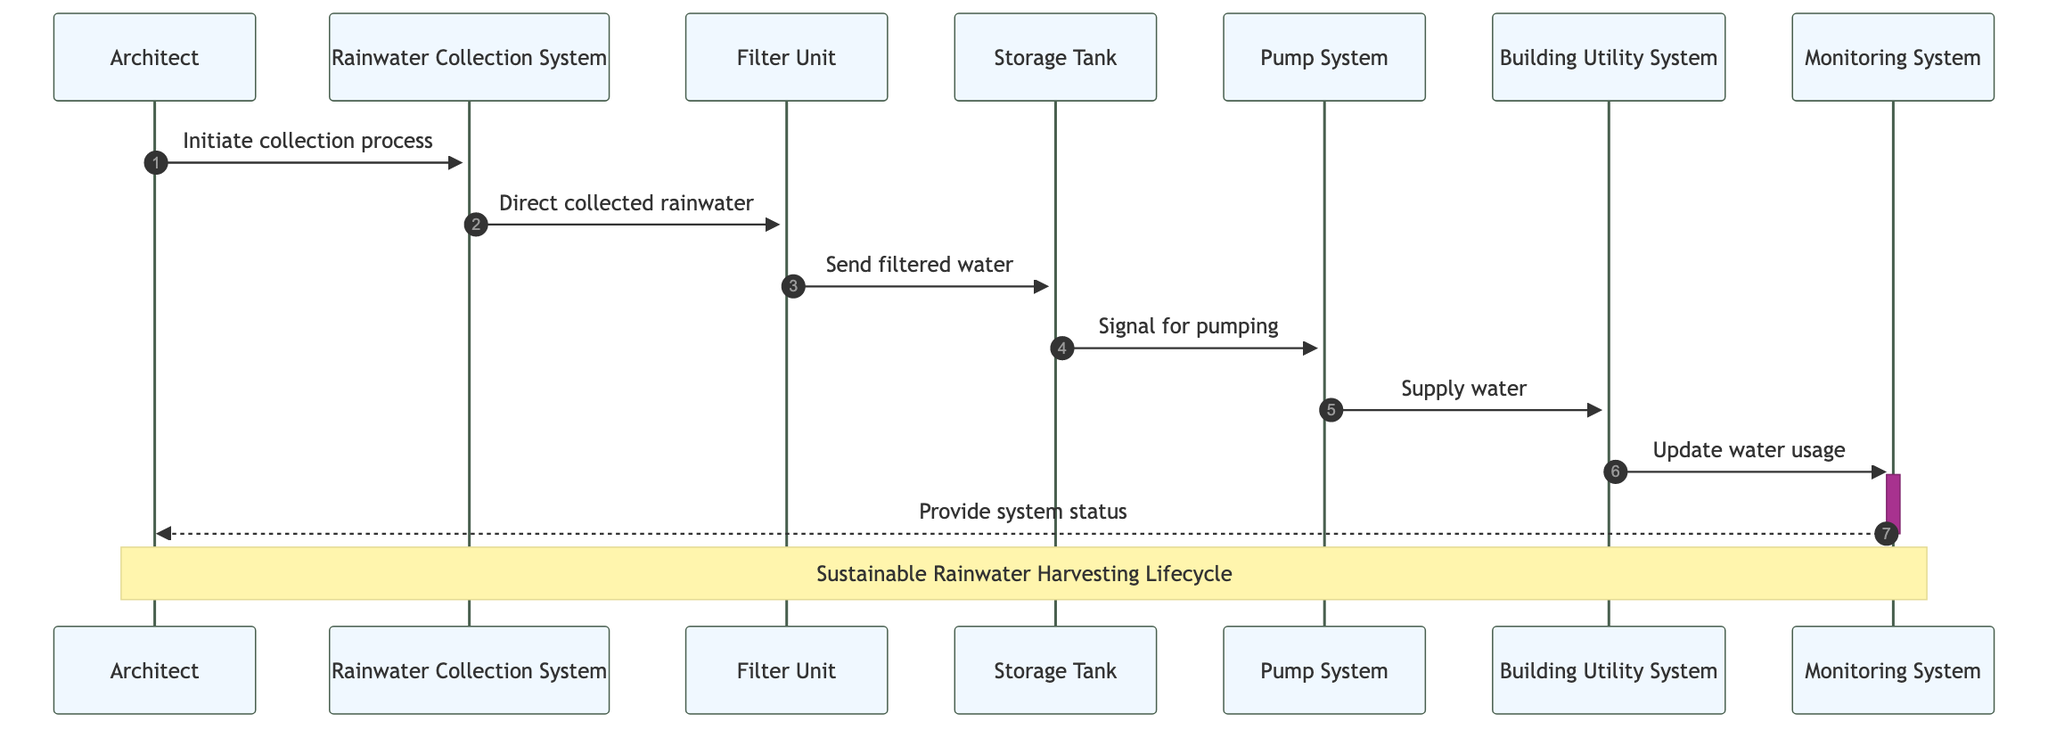What is the first action initiated by the Architect? The Architect initiates the process by sending the message "Initiate collection process" to the Rainwater Collection System. This is represented as the first message in the sequence diagram, indicating the starting point of the lifecycle.
Answer: Initiate collection process How many entities are involved in the system? The participants listed include a total of six entities: Rainwater Collection System, Filter Unit, Storage Tank, Pump System, Building Utility System, and Monitoring System. Counting these gives us the total number of entities involved.
Answer: Six What does the Filter Unit do after it receives rainwater? After receiving rainwater from the Rainwater Collection System, the Filter Unit processes the water and sends the filtered water to the Storage Tank, as denoted by the message "Send filtered water."
Answer: Send filtered water Which component provides the system status back to the Architect? The Monitoring System is responsible for providing the system status back to the Architect, as indicated by the final message in the sequence diagram: "Provide system status." This message indicates the communication flow back to the Architect after monitoring the system's activities.
Answer: Monitoring System What action does the Pump System perform? The Pump System performs the action of supplying water to the Building Utility System after receiving the signal for pumping from the Storage Tank, as shown in the message "Supply water."
Answer: Supply water What is the last interaction in the lifecycle? The last interaction in the sequence is when the Monitoring System sends a status update to the Architect, which completes the information cycle of the system's operations. This interaction signifies the conclusion of the sequence of messages.
Answer: Provide system status What entity does the Storage Tank signal for action? The Storage Tank sends a signal for pumping to the Pump System. This step indicates that the filtered water stored needs to be utilized, which is crucial for the operational process of the harvesting system.
Answer: Pump System What is the relationship between the Filter Unit and the Storage Tank? The relationship is that the Filter Unit sends the filtered water to the Storage Tank. This indicates the flow of processed water within the lifecycle of the rainwater harvesting system, emphasizing the importance of filtration before storage.
Answer: Send filtered water 